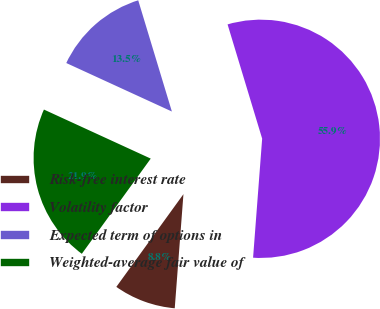<chart> <loc_0><loc_0><loc_500><loc_500><pie_chart><fcel>Risk-free interest rate<fcel>Volatility factor<fcel>Expected term of options in<fcel>Weighted-average fair value of<nl><fcel>8.76%<fcel>55.89%<fcel>13.47%<fcel>21.88%<nl></chart> 